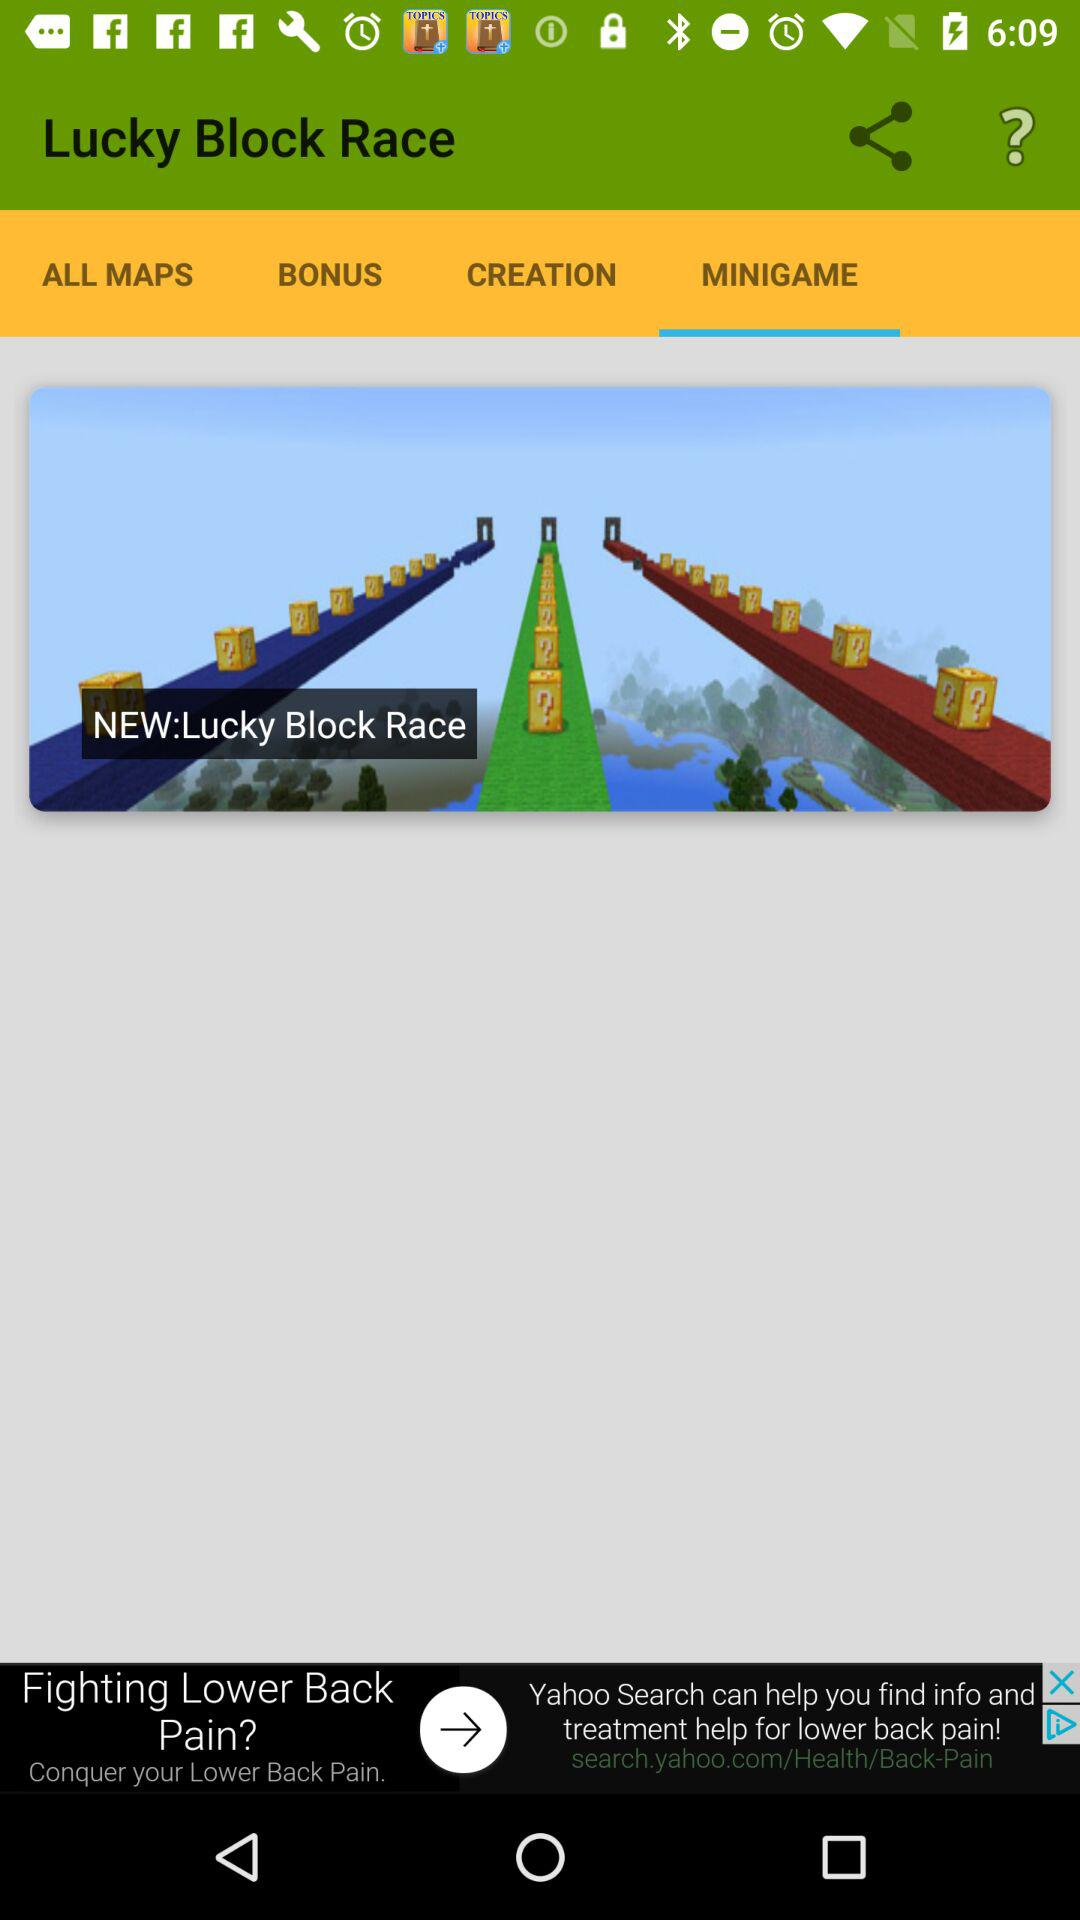What is the name of the "MINIGAME"? The name of the "MINIGAME" is "NEW:Lucky Block Race". 